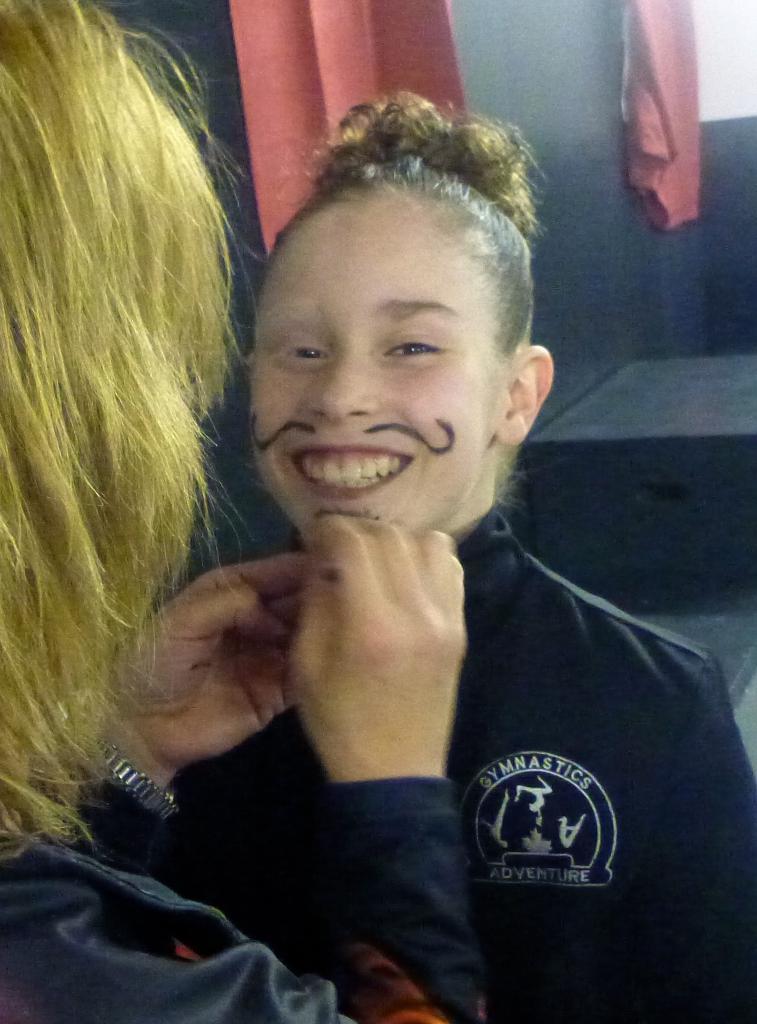Could you give a brief overview of what you see in this image? In this image we can see two people. They are wearing jackets. In the background, we can see the wall and curtains. 